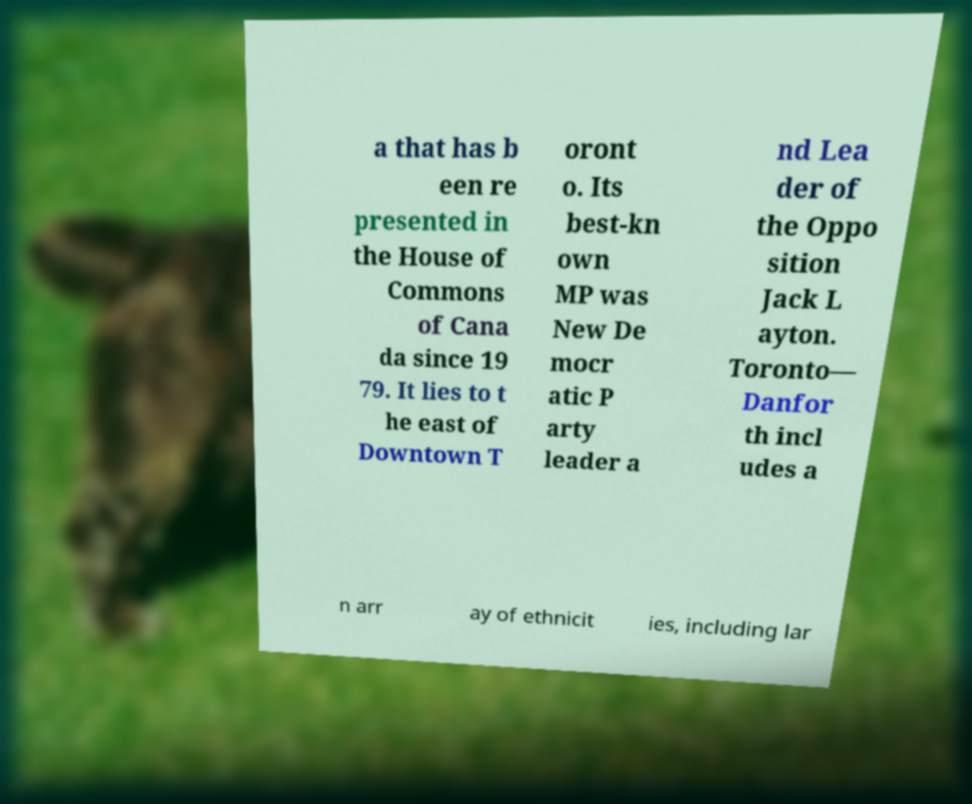Can you read and provide the text displayed in the image?This photo seems to have some interesting text. Can you extract and type it out for me? a that has b een re presented in the House of Commons of Cana da since 19 79. It lies to t he east of Downtown T oront o. Its best-kn own MP was New De mocr atic P arty leader a nd Lea der of the Oppo sition Jack L ayton. Toronto— Danfor th incl udes a n arr ay of ethnicit ies, including lar 